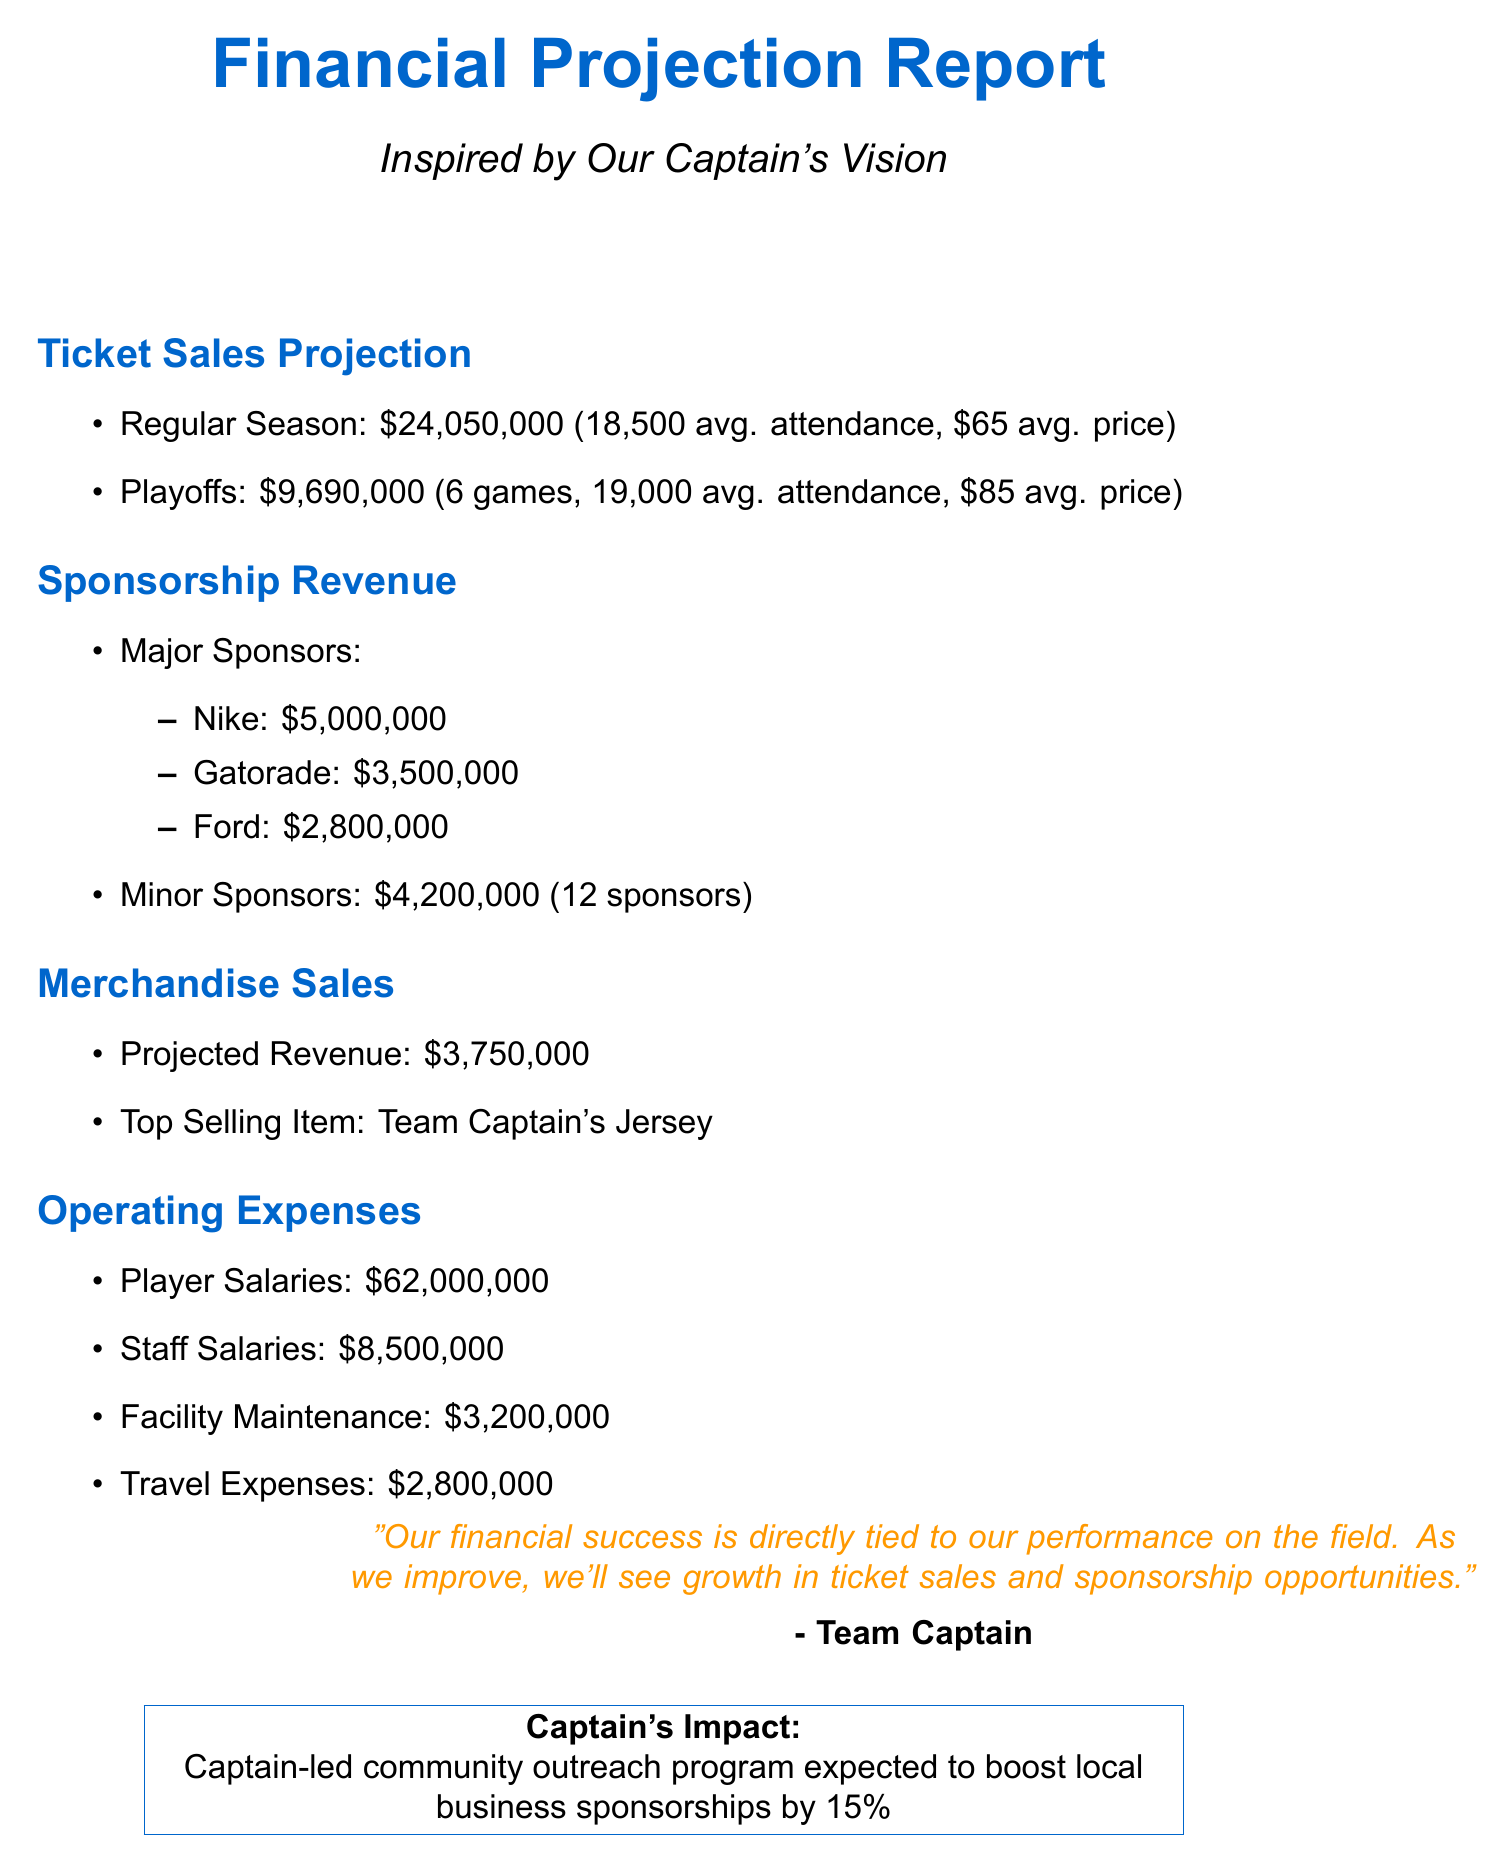What is the expected total revenue from regular season ticket sales? The total revenue from regular season ticket sales is listed in the document as $24,050,000.
Answer: $24,050,000 What is the average ticket price for playoffs? The document states the average ticket price for playoffs is $85.
Answer: $85 How many estimated playoff games are projected? The document indicates that there are estimated to be 6 playoff games.
Answer: 6 What is the combined value of minor sponsors? The combined value of minor sponsors is $4,200,000 according to the document.
Answer: $4,200,000 What is the projected revenue from merchandise sales? The projected revenue from merchandise sales is noted as $3,750,000 in the report.
Answer: $3,750,000 What is the total amount earmarked for player salaries? The document details that the amount for player salaries is $62,000,000.
Answer: $62,000,000 Which item is projected to be the top selling merchandise? The report mentions that the top selling item is the Team Captain's Jersey.
Answer: Team Captain's Jersey What impact is expected from the captain-led community outreach program? The document states that the program is expected to boost local business sponsorships by 15%.
Answer: 15% What sponsor has the highest value? The document identifies Nike as the sponsor with the highest value at $5,000,000.
Answer: Nike 